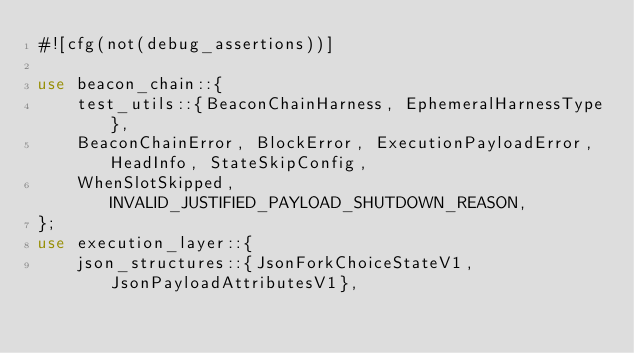<code> <loc_0><loc_0><loc_500><loc_500><_Rust_>#![cfg(not(debug_assertions))]

use beacon_chain::{
    test_utils::{BeaconChainHarness, EphemeralHarnessType},
    BeaconChainError, BlockError, ExecutionPayloadError, HeadInfo, StateSkipConfig,
    WhenSlotSkipped, INVALID_JUSTIFIED_PAYLOAD_SHUTDOWN_REASON,
};
use execution_layer::{
    json_structures::{JsonForkChoiceStateV1, JsonPayloadAttributesV1},</code> 